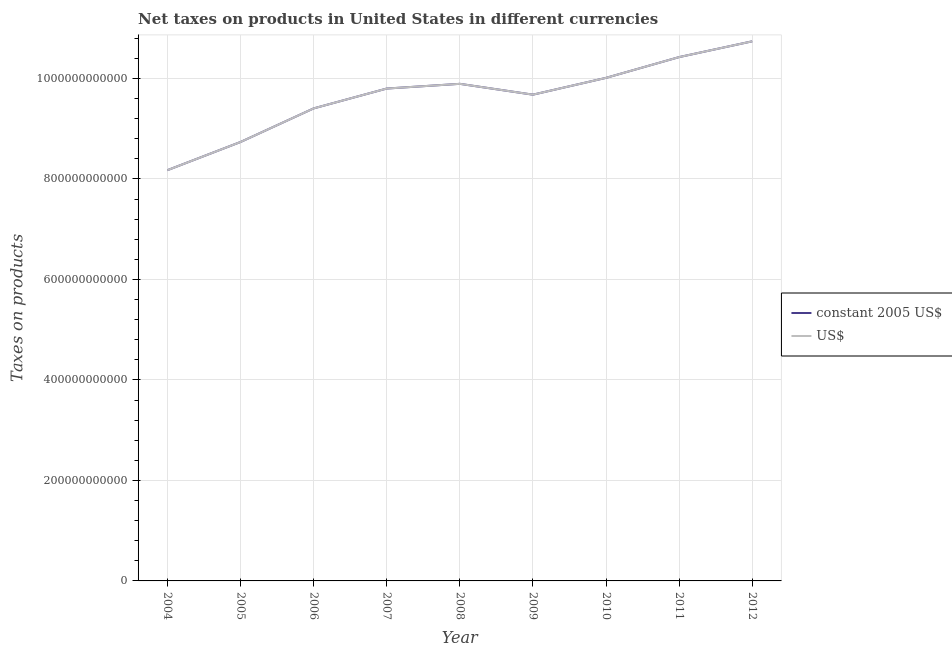Does the line corresponding to net taxes in us$ intersect with the line corresponding to net taxes in constant 2005 us$?
Make the answer very short. Yes. What is the net taxes in constant 2005 us$ in 2005?
Offer a terse response. 8.74e+11. Across all years, what is the maximum net taxes in us$?
Make the answer very short. 1.07e+12. Across all years, what is the minimum net taxes in constant 2005 us$?
Ensure brevity in your answer.  8.18e+11. In which year was the net taxes in constant 2005 us$ maximum?
Keep it short and to the point. 2012. In which year was the net taxes in constant 2005 us$ minimum?
Give a very brief answer. 2004. What is the total net taxes in us$ in the graph?
Give a very brief answer. 8.69e+12. What is the difference between the net taxes in constant 2005 us$ in 2011 and that in 2012?
Your answer should be very brief. -3.14e+1. What is the difference between the net taxes in constant 2005 us$ in 2012 and the net taxes in us$ in 2006?
Provide a succinct answer. 1.34e+11. What is the average net taxes in constant 2005 us$ per year?
Provide a short and direct response. 9.65e+11. In the year 2008, what is the difference between the net taxes in constant 2005 us$ and net taxes in us$?
Provide a succinct answer. 0. In how many years, is the net taxes in us$ greater than 320000000000 units?
Keep it short and to the point. 9. What is the ratio of the net taxes in constant 2005 us$ in 2004 to that in 2007?
Offer a very short reply. 0.83. Is the net taxes in us$ in 2009 less than that in 2010?
Ensure brevity in your answer.  Yes. What is the difference between the highest and the second highest net taxes in constant 2005 us$?
Your answer should be very brief. 3.14e+1. What is the difference between the highest and the lowest net taxes in constant 2005 us$?
Provide a short and direct response. 2.56e+11. In how many years, is the net taxes in constant 2005 us$ greater than the average net taxes in constant 2005 us$ taken over all years?
Provide a short and direct response. 6. Does the net taxes in constant 2005 us$ monotonically increase over the years?
Keep it short and to the point. No. Is the net taxes in constant 2005 us$ strictly less than the net taxes in us$ over the years?
Your answer should be compact. No. How many lines are there?
Offer a terse response. 2. How many years are there in the graph?
Your answer should be compact. 9. What is the difference between two consecutive major ticks on the Y-axis?
Ensure brevity in your answer.  2.00e+11. Are the values on the major ticks of Y-axis written in scientific E-notation?
Ensure brevity in your answer.  No. Where does the legend appear in the graph?
Your response must be concise. Center right. How many legend labels are there?
Your response must be concise. 2. What is the title of the graph?
Your answer should be very brief. Net taxes on products in United States in different currencies. What is the label or title of the Y-axis?
Provide a succinct answer. Taxes on products. What is the Taxes on products in constant 2005 US$ in 2004?
Your answer should be very brief. 8.18e+11. What is the Taxes on products of US$ in 2004?
Ensure brevity in your answer.  8.18e+11. What is the Taxes on products in constant 2005 US$ in 2005?
Provide a succinct answer. 8.74e+11. What is the Taxes on products of US$ in 2005?
Keep it short and to the point. 8.74e+11. What is the Taxes on products of constant 2005 US$ in 2006?
Offer a terse response. 9.40e+11. What is the Taxes on products of US$ in 2006?
Your answer should be compact. 9.40e+11. What is the Taxes on products in constant 2005 US$ in 2007?
Provide a short and direct response. 9.80e+11. What is the Taxes on products in US$ in 2007?
Provide a succinct answer. 9.80e+11. What is the Taxes on products in constant 2005 US$ in 2008?
Offer a terse response. 9.89e+11. What is the Taxes on products in US$ in 2008?
Give a very brief answer. 9.89e+11. What is the Taxes on products in constant 2005 US$ in 2009?
Provide a succinct answer. 9.68e+11. What is the Taxes on products in US$ in 2009?
Give a very brief answer. 9.68e+11. What is the Taxes on products of constant 2005 US$ in 2010?
Provide a short and direct response. 1.00e+12. What is the Taxes on products in US$ in 2010?
Give a very brief answer. 1.00e+12. What is the Taxes on products of constant 2005 US$ in 2011?
Your answer should be very brief. 1.04e+12. What is the Taxes on products of US$ in 2011?
Make the answer very short. 1.04e+12. What is the Taxes on products of constant 2005 US$ in 2012?
Provide a short and direct response. 1.07e+12. What is the Taxes on products of US$ in 2012?
Give a very brief answer. 1.07e+12. Across all years, what is the maximum Taxes on products of constant 2005 US$?
Keep it short and to the point. 1.07e+12. Across all years, what is the maximum Taxes on products of US$?
Offer a terse response. 1.07e+12. Across all years, what is the minimum Taxes on products in constant 2005 US$?
Keep it short and to the point. 8.18e+11. Across all years, what is the minimum Taxes on products of US$?
Your answer should be very brief. 8.18e+11. What is the total Taxes on products of constant 2005 US$ in the graph?
Offer a very short reply. 8.69e+12. What is the total Taxes on products in US$ in the graph?
Keep it short and to the point. 8.69e+12. What is the difference between the Taxes on products in constant 2005 US$ in 2004 and that in 2005?
Your response must be concise. -5.61e+1. What is the difference between the Taxes on products of US$ in 2004 and that in 2005?
Ensure brevity in your answer.  -5.61e+1. What is the difference between the Taxes on products of constant 2005 US$ in 2004 and that in 2006?
Offer a very short reply. -1.23e+11. What is the difference between the Taxes on products in US$ in 2004 and that in 2006?
Provide a succinct answer. -1.23e+11. What is the difference between the Taxes on products of constant 2005 US$ in 2004 and that in 2007?
Make the answer very short. -1.62e+11. What is the difference between the Taxes on products of US$ in 2004 and that in 2007?
Give a very brief answer. -1.62e+11. What is the difference between the Taxes on products of constant 2005 US$ in 2004 and that in 2008?
Your answer should be very brief. -1.72e+11. What is the difference between the Taxes on products of US$ in 2004 and that in 2008?
Offer a very short reply. -1.72e+11. What is the difference between the Taxes on products of constant 2005 US$ in 2004 and that in 2009?
Keep it short and to the point. -1.50e+11. What is the difference between the Taxes on products in US$ in 2004 and that in 2009?
Offer a very short reply. -1.50e+11. What is the difference between the Taxes on products of constant 2005 US$ in 2004 and that in 2010?
Provide a succinct answer. -1.84e+11. What is the difference between the Taxes on products of US$ in 2004 and that in 2010?
Ensure brevity in your answer.  -1.84e+11. What is the difference between the Taxes on products of constant 2005 US$ in 2004 and that in 2011?
Offer a terse response. -2.25e+11. What is the difference between the Taxes on products in US$ in 2004 and that in 2011?
Your answer should be very brief. -2.25e+11. What is the difference between the Taxes on products in constant 2005 US$ in 2004 and that in 2012?
Your answer should be compact. -2.56e+11. What is the difference between the Taxes on products in US$ in 2004 and that in 2012?
Make the answer very short. -2.56e+11. What is the difference between the Taxes on products in constant 2005 US$ in 2005 and that in 2006?
Give a very brief answer. -6.69e+1. What is the difference between the Taxes on products in US$ in 2005 and that in 2006?
Provide a short and direct response. -6.69e+1. What is the difference between the Taxes on products of constant 2005 US$ in 2005 and that in 2007?
Offer a very short reply. -1.06e+11. What is the difference between the Taxes on products in US$ in 2005 and that in 2007?
Provide a short and direct response. -1.06e+11. What is the difference between the Taxes on products of constant 2005 US$ in 2005 and that in 2008?
Offer a terse response. -1.16e+11. What is the difference between the Taxes on products in US$ in 2005 and that in 2008?
Your answer should be very brief. -1.16e+11. What is the difference between the Taxes on products in constant 2005 US$ in 2005 and that in 2009?
Your response must be concise. -9.42e+1. What is the difference between the Taxes on products in US$ in 2005 and that in 2009?
Provide a short and direct response. -9.42e+1. What is the difference between the Taxes on products of constant 2005 US$ in 2005 and that in 2010?
Offer a terse response. -1.28e+11. What is the difference between the Taxes on products in US$ in 2005 and that in 2010?
Offer a very short reply. -1.28e+11. What is the difference between the Taxes on products of constant 2005 US$ in 2005 and that in 2011?
Offer a terse response. -1.69e+11. What is the difference between the Taxes on products in US$ in 2005 and that in 2011?
Give a very brief answer. -1.69e+11. What is the difference between the Taxes on products in constant 2005 US$ in 2005 and that in 2012?
Provide a short and direct response. -2.00e+11. What is the difference between the Taxes on products of US$ in 2005 and that in 2012?
Your answer should be very brief. -2.00e+11. What is the difference between the Taxes on products in constant 2005 US$ in 2006 and that in 2007?
Provide a succinct answer. -3.95e+1. What is the difference between the Taxes on products in US$ in 2006 and that in 2007?
Provide a succinct answer. -3.95e+1. What is the difference between the Taxes on products in constant 2005 US$ in 2006 and that in 2008?
Make the answer very short. -4.89e+1. What is the difference between the Taxes on products in US$ in 2006 and that in 2008?
Ensure brevity in your answer.  -4.89e+1. What is the difference between the Taxes on products in constant 2005 US$ in 2006 and that in 2009?
Offer a terse response. -2.73e+1. What is the difference between the Taxes on products of US$ in 2006 and that in 2009?
Your answer should be very brief. -2.73e+1. What is the difference between the Taxes on products in constant 2005 US$ in 2006 and that in 2010?
Your response must be concise. -6.08e+1. What is the difference between the Taxes on products in US$ in 2006 and that in 2010?
Your response must be concise. -6.08e+1. What is the difference between the Taxes on products of constant 2005 US$ in 2006 and that in 2011?
Your answer should be compact. -1.02e+11. What is the difference between the Taxes on products of US$ in 2006 and that in 2011?
Keep it short and to the point. -1.02e+11. What is the difference between the Taxes on products in constant 2005 US$ in 2006 and that in 2012?
Provide a succinct answer. -1.34e+11. What is the difference between the Taxes on products in US$ in 2006 and that in 2012?
Make the answer very short. -1.34e+11. What is the difference between the Taxes on products in constant 2005 US$ in 2007 and that in 2008?
Your answer should be compact. -9.38e+09. What is the difference between the Taxes on products of US$ in 2007 and that in 2008?
Make the answer very short. -9.38e+09. What is the difference between the Taxes on products of constant 2005 US$ in 2007 and that in 2009?
Keep it short and to the point. 1.22e+1. What is the difference between the Taxes on products in US$ in 2007 and that in 2009?
Provide a short and direct response. 1.22e+1. What is the difference between the Taxes on products in constant 2005 US$ in 2007 and that in 2010?
Ensure brevity in your answer.  -2.13e+1. What is the difference between the Taxes on products of US$ in 2007 and that in 2010?
Offer a very short reply. -2.13e+1. What is the difference between the Taxes on products in constant 2005 US$ in 2007 and that in 2011?
Provide a short and direct response. -6.26e+1. What is the difference between the Taxes on products in US$ in 2007 and that in 2011?
Ensure brevity in your answer.  -6.26e+1. What is the difference between the Taxes on products of constant 2005 US$ in 2007 and that in 2012?
Your answer should be compact. -9.40e+1. What is the difference between the Taxes on products in US$ in 2007 and that in 2012?
Offer a terse response. -9.40e+1. What is the difference between the Taxes on products in constant 2005 US$ in 2008 and that in 2009?
Offer a very short reply. 2.16e+1. What is the difference between the Taxes on products in US$ in 2008 and that in 2009?
Provide a short and direct response. 2.16e+1. What is the difference between the Taxes on products of constant 2005 US$ in 2008 and that in 2010?
Provide a short and direct response. -1.19e+1. What is the difference between the Taxes on products in US$ in 2008 and that in 2010?
Your answer should be compact. -1.19e+1. What is the difference between the Taxes on products in constant 2005 US$ in 2008 and that in 2011?
Offer a terse response. -5.32e+1. What is the difference between the Taxes on products of US$ in 2008 and that in 2011?
Your answer should be compact. -5.32e+1. What is the difference between the Taxes on products of constant 2005 US$ in 2008 and that in 2012?
Your answer should be compact. -8.46e+1. What is the difference between the Taxes on products of US$ in 2008 and that in 2012?
Your response must be concise. -8.46e+1. What is the difference between the Taxes on products in constant 2005 US$ in 2009 and that in 2010?
Keep it short and to the point. -3.34e+1. What is the difference between the Taxes on products of US$ in 2009 and that in 2010?
Ensure brevity in your answer.  -3.34e+1. What is the difference between the Taxes on products of constant 2005 US$ in 2009 and that in 2011?
Give a very brief answer. -7.48e+1. What is the difference between the Taxes on products of US$ in 2009 and that in 2011?
Your response must be concise. -7.48e+1. What is the difference between the Taxes on products in constant 2005 US$ in 2009 and that in 2012?
Provide a succinct answer. -1.06e+11. What is the difference between the Taxes on products in US$ in 2009 and that in 2012?
Your answer should be compact. -1.06e+11. What is the difference between the Taxes on products of constant 2005 US$ in 2010 and that in 2011?
Ensure brevity in your answer.  -4.13e+1. What is the difference between the Taxes on products of US$ in 2010 and that in 2011?
Offer a terse response. -4.13e+1. What is the difference between the Taxes on products in constant 2005 US$ in 2010 and that in 2012?
Give a very brief answer. -7.27e+1. What is the difference between the Taxes on products in US$ in 2010 and that in 2012?
Keep it short and to the point. -7.27e+1. What is the difference between the Taxes on products in constant 2005 US$ in 2011 and that in 2012?
Your answer should be compact. -3.14e+1. What is the difference between the Taxes on products of US$ in 2011 and that in 2012?
Keep it short and to the point. -3.14e+1. What is the difference between the Taxes on products in constant 2005 US$ in 2004 and the Taxes on products in US$ in 2005?
Your response must be concise. -5.61e+1. What is the difference between the Taxes on products of constant 2005 US$ in 2004 and the Taxes on products of US$ in 2006?
Offer a terse response. -1.23e+11. What is the difference between the Taxes on products in constant 2005 US$ in 2004 and the Taxes on products in US$ in 2007?
Your response must be concise. -1.62e+11. What is the difference between the Taxes on products in constant 2005 US$ in 2004 and the Taxes on products in US$ in 2008?
Your response must be concise. -1.72e+11. What is the difference between the Taxes on products of constant 2005 US$ in 2004 and the Taxes on products of US$ in 2009?
Offer a terse response. -1.50e+11. What is the difference between the Taxes on products of constant 2005 US$ in 2004 and the Taxes on products of US$ in 2010?
Your answer should be compact. -1.84e+11. What is the difference between the Taxes on products in constant 2005 US$ in 2004 and the Taxes on products in US$ in 2011?
Provide a short and direct response. -2.25e+11. What is the difference between the Taxes on products of constant 2005 US$ in 2004 and the Taxes on products of US$ in 2012?
Offer a very short reply. -2.56e+11. What is the difference between the Taxes on products of constant 2005 US$ in 2005 and the Taxes on products of US$ in 2006?
Make the answer very short. -6.69e+1. What is the difference between the Taxes on products of constant 2005 US$ in 2005 and the Taxes on products of US$ in 2007?
Your response must be concise. -1.06e+11. What is the difference between the Taxes on products in constant 2005 US$ in 2005 and the Taxes on products in US$ in 2008?
Give a very brief answer. -1.16e+11. What is the difference between the Taxes on products of constant 2005 US$ in 2005 and the Taxes on products of US$ in 2009?
Give a very brief answer. -9.42e+1. What is the difference between the Taxes on products of constant 2005 US$ in 2005 and the Taxes on products of US$ in 2010?
Provide a succinct answer. -1.28e+11. What is the difference between the Taxes on products of constant 2005 US$ in 2005 and the Taxes on products of US$ in 2011?
Provide a short and direct response. -1.69e+11. What is the difference between the Taxes on products of constant 2005 US$ in 2005 and the Taxes on products of US$ in 2012?
Offer a very short reply. -2.00e+11. What is the difference between the Taxes on products in constant 2005 US$ in 2006 and the Taxes on products in US$ in 2007?
Keep it short and to the point. -3.95e+1. What is the difference between the Taxes on products in constant 2005 US$ in 2006 and the Taxes on products in US$ in 2008?
Your answer should be very brief. -4.89e+1. What is the difference between the Taxes on products of constant 2005 US$ in 2006 and the Taxes on products of US$ in 2009?
Ensure brevity in your answer.  -2.73e+1. What is the difference between the Taxes on products in constant 2005 US$ in 2006 and the Taxes on products in US$ in 2010?
Give a very brief answer. -6.08e+1. What is the difference between the Taxes on products in constant 2005 US$ in 2006 and the Taxes on products in US$ in 2011?
Offer a very short reply. -1.02e+11. What is the difference between the Taxes on products in constant 2005 US$ in 2006 and the Taxes on products in US$ in 2012?
Provide a short and direct response. -1.34e+11. What is the difference between the Taxes on products of constant 2005 US$ in 2007 and the Taxes on products of US$ in 2008?
Your response must be concise. -9.38e+09. What is the difference between the Taxes on products in constant 2005 US$ in 2007 and the Taxes on products in US$ in 2009?
Give a very brief answer. 1.22e+1. What is the difference between the Taxes on products in constant 2005 US$ in 2007 and the Taxes on products in US$ in 2010?
Give a very brief answer. -2.13e+1. What is the difference between the Taxes on products of constant 2005 US$ in 2007 and the Taxes on products of US$ in 2011?
Make the answer very short. -6.26e+1. What is the difference between the Taxes on products of constant 2005 US$ in 2007 and the Taxes on products of US$ in 2012?
Your response must be concise. -9.40e+1. What is the difference between the Taxes on products of constant 2005 US$ in 2008 and the Taxes on products of US$ in 2009?
Offer a terse response. 2.16e+1. What is the difference between the Taxes on products in constant 2005 US$ in 2008 and the Taxes on products in US$ in 2010?
Your answer should be very brief. -1.19e+1. What is the difference between the Taxes on products of constant 2005 US$ in 2008 and the Taxes on products of US$ in 2011?
Offer a terse response. -5.32e+1. What is the difference between the Taxes on products in constant 2005 US$ in 2008 and the Taxes on products in US$ in 2012?
Provide a succinct answer. -8.46e+1. What is the difference between the Taxes on products in constant 2005 US$ in 2009 and the Taxes on products in US$ in 2010?
Give a very brief answer. -3.34e+1. What is the difference between the Taxes on products in constant 2005 US$ in 2009 and the Taxes on products in US$ in 2011?
Your answer should be very brief. -7.48e+1. What is the difference between the Taxes on products of constant 2005 US$ in 2009 and the Taxes on products of US$ in 2012?
Offer a very short reply. -1.06e+11. What is the difference between the Taxes on products of constant 2005 US$ in 2010 and the Taxes on products of US$ in 2011?
Your answer should be very brief. -4.13e+1. What is the difference between the Taxes on products of constant 2005 US$ in 2010 and the Taxes on products of US$ in 2012?
Your answer should be very brief. -7.27e+1. What is the difference between the Taxes on products of constant 2005 US$ in 2011 and the Taxes on products of US$ in 2012?
Your answer should be very brief. -3.14e+1. What is the average Taxes on products of constant 2005 US$ per year?
Make the answer very short. 9.65e+11. What is the average Taxes on products of US$ per year?
Provide a succinct answer. 9.65e+11. In the year 2007, what is the difference between the Taxes on products in constant 2005 US$ and Taxes on products in US$?
Provide a short and direct response. 0. In the year 2009, what is the difference between the Taxes on products of constant 2005 US$ and Taxes on products of US$?
Offer a terse response. 0. In the year 2010, what is the difference between the Taxes on products of constant 2005 US$ and Taxes on products of US$?
Offer a very short reply. 0. What is the ratio of the Taxes on products of constant 2005 US$ in 2004 to that in 2005?
Your answer should be compact. 0.94. What is the ratio of the Taxes on products of US$ in 2004 to that in 2005?
Ensure brevity in your answer.  0.94. What is the ratio of the Taxes on products of constant 2005 US$ in 2004 to that in 2006?
Provide a short and direct response. 0.87. What is the ratio of the Taxes on products in US$ in 2004 to that in 2006?
Ensure brevity in your answer.  0.87. What is the ratio of the Taxes on products in constant 2005 US$ in 2004 to that in 2007?
Give a very brief answer. 0.83. What is the ratio of the Taxes on products in US$ in 2004 to that in 2007?
Your response must be concise. 0.83. What is the ratio of the Taxes on products of constant 2005 US$ in 2004 to that in 2008?
Offer a terse response. 0.83. What is the ratio of the Taxes on products in US$ in 2004 to that in 2008?
Give a very brief answer. 0.83. What is the ratio of the Taxes on products in constant 2005 US$ in 2004 to that in 2009?
Your answer should be compact. 0.84. What is the ratio of the Taxes on products of US$ in 2004 to that in 2009?
Offer a very short reply. 0.84. What is the ratio of the Taxes on products in constant 2005 US$ in 2004 to that in 2010?
Offer a terse response. 0.82. What is the ratio of the Taxes on products of US$ in 2004 to that in 2010?
Your answer should be compact. 0.82. What is the ratio of the Taxes on products of constant 2005 US$ in 2004 to that in 2011?
Provide a short and direct response. 0.78. What is the ratio of the Taxes on products in US$ in 2004 to that in 2011?
Make the answer very short. 0.78. What is the ratio of the Taxes on products of constant 2005 US$ in 2004 to that in 2012?
Ensure brevity in your answer.  0.76. What is the ratio of the Taxes on products in US$ in 2004 to that in 2012?
Provide a short and direct response. 0.76. What is the ratio of the Taxes on products of constant 2005 US$ in 2005 to that in 2006?
Your answer should be compact. 0.93. What is the ratio of the Taxes on products in US$ in 2005 to that in 2006?
Provide a short and direct response. 0.93. What is the ratio of the Taxes on products of constant 2005 US$ in 2005 to that in 2007?
Provide a succinct answer. 0.89. What is the ratio of the Taxes on products in US$ in 2005 to that in 2007?
Keep it short and to the point. 0.89. What is the ratio of the Taxes on products of constant 2005 US$ in 2005 to that in 2008?
Your response must be concise. 0.88. What is the ratio of the Taxes on products in US$ in 2005 to that in 2008?
Ensure brevity in your answer.  0.88. What is the ratio of the Taxes on products of constant 2005 US$ in 2005 to that in 2009?
Give a very brief answer. 0.9. What is the ratio of the Taxes on products in US$ in 2005 to that in 2009?
Your answer should be very brief. 0.9. What is the ratio of the Taxes on products in constant 2005 US$ in 2005 to that in 2010?
Keep it short and to the point. 0.87. What is the ratio of the Taxes on products in US$ in 2005 to that in 2010?
Make the answer very short. 0.87. What is the ratio of the Taxes on products of constant 2005 US$ in 2005 to that in 2011?
Keep it short and to the point. 0.84. What is the ratio of the Taxes on products in US$ in 2005 to that in 2011?
Offer a very short reply. 0.84. What is the ratio of the Taxes on products of constant 2005 US$ in 2005 to that in 2012?
Ensure brevity in your answer.  0.81. What is the ratio of the Taxes on products in US$ in 2005 to that in 2012?
Provide a succinct answer. 0.81. What is the ratio of the Taxes on products in constant 2005 US$ in 2006 to that in 2007?
Ensure brevity in your answer.  0.96. What is the ratio of the Taxes on products in US$ in 2006 to that in 2007?
Keep it short and to the point. 0.96. What is the ratio of the Taxes on products of constant 2005 US$ in 2006 to that in 2008?
Your response must be concise. 0.95. What is the ratio of the Taxes on products in US$ in 2006 to that in 2008?
Your answer should be very brief. 0.95. What is the ratio of the Taxes on products in constant 2005 US$ in 2006 to that in 2009?
Ensure brevity in your answer.  0.97. What is the ratio of the Taxes on products of US$ in 2006 to that in 2009?
Offer a terse response. 0.97. What is the ratio of the Taxes on products in constant 2005 US$ in 2006 to that in 2010?
Offer a very short reply. 0.94. What is the ratio of the Taxes on products in US$ in 2006 to that in 2010?
Ensure brevity in your answer.  0.94. What is the ratio of the Taxes on products of constant 2005 US$ in 2006 to that in 2011?
Keep it short and to the point. 0.9. What is the ratio of the Taxes on products of US$ in 2006 to that in 2011?
Provide a succinct answer. 0.9. What is the ratio of the Taxes on products in constant 2005 US$ in 2006 to that in 2012?
Your answer should be compact. 0.88. What is the ratio of the Taxes on products of US$ in 2006 to that in 2012?
Make the answer very short. 0.88. What is the ratio of the Taxes on products of US$ in 2007 to that in 2008?
Offer a very short reply. 0.99. What is the ratio of the Taxes on products of constant 2005 US$ in 2007 to that in 2009?
Provide a succinct answer. 1.01. What is the ratio of the Taxes on products of US$ in 2007 to that in 2009?
Your response must be concise. 1.01. What is the ratio of the Taxes on products of constant 2005 US$ in 2007 to that in 2010?
Offer a very short reply. 0.98. What is the ratio of the Taxes on products in US$ in 2007 to that in 2010?
Offer a very short reply. 0.98. What is the ratio of the Taxes on products in constant 2005 US$ in 2007 to that in 2011?
Your response must be concise. 0.94. What is the ratio of the Taxes on products in constant 2005 US$ in 2007 to that in 2012?
Keep it short and to the point. 0.91. What is the ratio of the Taxes on products in US$ in 2007 to that in 2012?
Your answer should be compact. 0.91. What is the ratio of the Taxes on products in constant 2005 US$ in 2008 to that in 2009?
Your answer should be very brief. 1.02. What is the ratio of the Taxes on products of US$ in 2008 to that in 2009?
Offer a very short reply. 1.02. What is the ratio of the Taxes on products of US$ in 2008 to that in 2010?
Your answer should be compact. 0.99. What is the ratio of the Taxes on products of constant 2005 US$ in 2008 to that in 2011?
Give a very brief answer. 0.95. What is the ratio of the Taxes on products in US$ in 2008 to that in 2011?
Offer a terse response. 0.95. What is the ratio of the Taxes on products of constant 2005 US$ in 2008 to that in 2012?
Give a very brief answer. 0.92. What is the ratio of the Taxes on products of US$ in 2008 to that in 2012?
Offer a terse response. 0.92. What is the ratio of the Taxes on products in constant 2005 US$ in 2009 to that in 2010?
Provide a succinct answer. 0.97. What is the ratio of the Taxes on products in US$ in 2009 to that in 2010?
Give a very brief answer. 0.97. What is the ratio of the Taxes on products in constant 2005 US$ in 2009 to that in 2011?
Keep it short and to the point. 0.93. What is the ratio of the Taxes on products of US$ in 2009 to that in 2011?
Offer a very short reply. 0.93. What is the ratio of the Taxes on products of constant 2005 US$ in 2009 to that in 2012?
Ensure brevity in your answer.  0.9. What is the ratio of the Taxes on products in US$ in 2009 to that in 2012?
Ensure brevity in your answer.  0.9. What is the ratio of the Taxes on products of constant 2005 US$ in 2010 to that in 2011?
Provide a succinct answer. 0.96. What is the ratio of the Taxes on products in US$ in 2010 to that in 2011?
Provide a short and direct response. 0.96. What is the ratio of the Taxes on products of constant 2005 US$ in 2010 to that in 2012?
Give a very brief answer. 0.93. What is the ratio of the Taxes on products in US$ in 2010 to that in 2012?
Your answer should be compact. 0.93. What is the ratio of the Taxes on products in constant 2005 US$ in 2011 to that in 2012?
Provide a succinct answer. 0.97. What is the ratio of the Taxes on products in US$ in 2011 to that in 2012?
Offer a very short reply. 0.97. What is the difference between the highest and the second highest Taxes on products in constant 2005 US$?
Offer a terse response. 3.14e+1. What is the difference between the highest and the second highest Taxes on products of US$?
Keep it short and to the point. 3.14e+1. What is the difference between the highest and the lowest Taxes on products of constant 2005 US$?
Make the answer very short. 2.56e+11. What is the difference between the highest and the lowest Taxes on products of US$?
Offer a very short reply. 2.56e+11. 